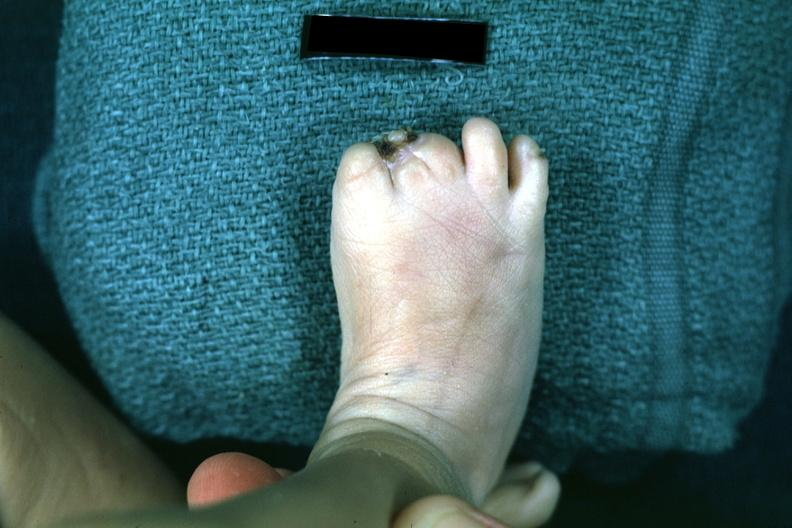does this image show syndactyly?
Answer the question using a single word or phrase. Yes 